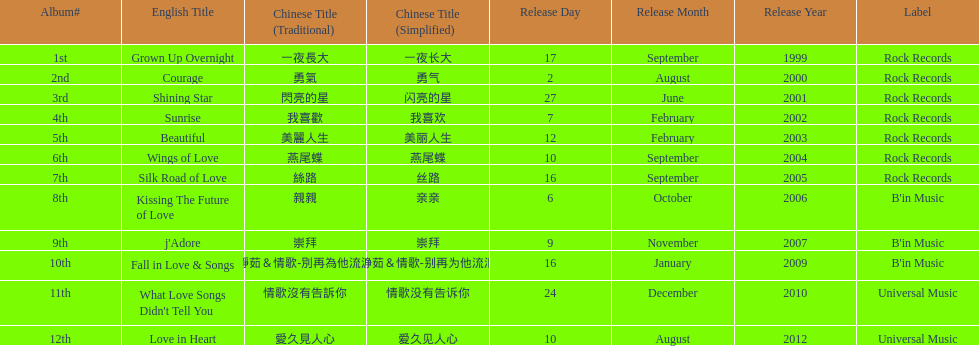Which was the only album to be released by b'in music in an even-numbered year? Kissing The Future of Love. 